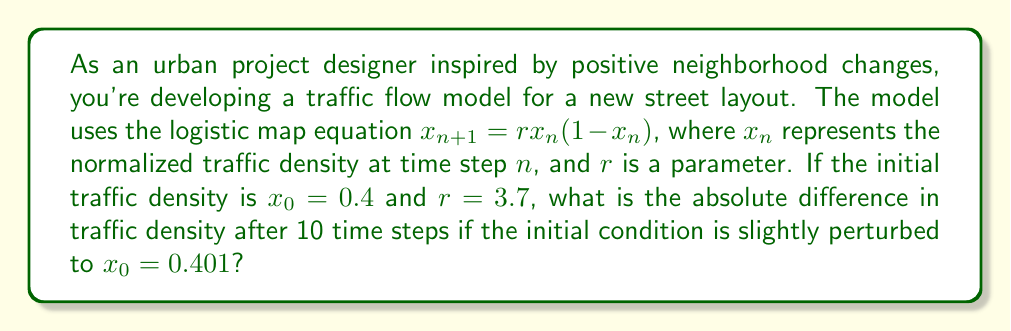Can you answer this question? To solve this problem, we need to iterate the logistic map equation for both initial conditions and compare the results after 10 steps. Let's call the two scenarios A (x_0 = 0.4) and B (x_0 = 0.401).

For scenario A:
1. $x_1 = 3.7 * 0.4 * (1 - 0.4) = 0.888$
2. $x_2 = 3.7 * 0.888 * (1 - 0.888) = 0.3681$
3. $x_3 = 3.7 * 0.3681 * (1 - 0.3681) = 0.8614$
4. $x_4 = 3.7 * 0.8614 * (1 - 0.8614) = 0.4415$
5. $x_5 = 3.7 * 0.4415 * (1 - 0.4415) = 0.9114$
6. $x_6 = 3.7 * 0.9114 * (1 - 0.9114) = 0.2984$
7. $x_7 = 3.7 * 0.2984 * (1 - 0.2984) = 0.7752$
8. $x_8 = 3.7 * 0.7752 * (1 - 0.7752) = 0.6443$
9. $x_9 = 3.7 * 0.6443 * (1 - 0.6443) = 0.8478$
10. $x_{10} = 3.7 * 0.8478 * (1 - 0.8478) = 0.4778$

For scenario B:
1. $x_1 = 3.7 * 0.401 * (1 - 0.401) = 0.8899$
2. $x_2 = 3.7 * 0.8899 * (1 - 0.8899) = 0.3638$
3. $x_3 = 3.7 * 0.3638 * (1 - 0.3638) = 0.8563$
4. $x_4 = 3.7 * 0.8563 * (1 - 0.8563) = 0.4543$
5. $x_5 = 3.7 * 0.4543 * (1 - 0.4543) = 0.9161$
6. $x_6 = 3.7 * 0.9161 * (1 - 0.9161) = 0.2850$
7. $x_7 = 3.7 * 0.2850 * (1 - 0.2850) = 0.7543$
8. $x_8 = 3.7 * 0.7543 * (1 - 0.7543) = 0.6866$
9. $x_9 = 3.7 * 0.6866 * (1 - 0.6866) = 0.7960$
10. $x_{10} = 3.7 * 0.7960 * (1 - 0.7960) = 0.6013$

The absolute difference after 10 steps is:
$$|x_{10,A} - x_{10,B}| = |0.4778 - 0.6013| = 0.1235$$

This significant difference demonstrates the sensitivity to initial conditions, a key characteristic of chaotic systems.
Answer: 0.1235 